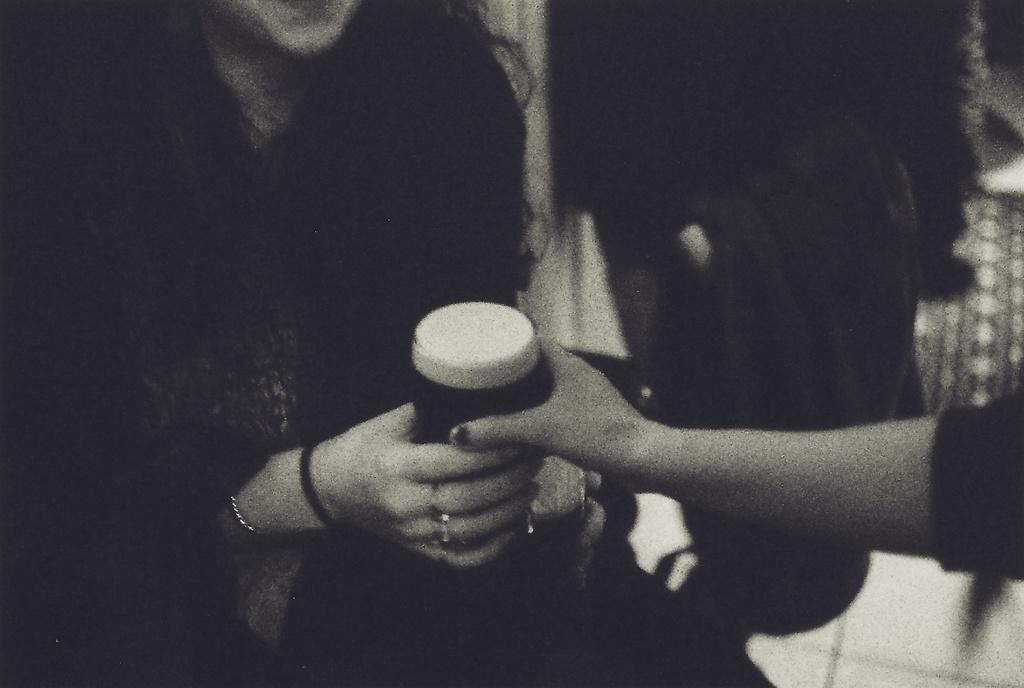What is the color scheme of the image? The image is black and white. How many people are in the image? There are two persons in the image. What are the two persons holding in their hands? The two persons are holding something in their hands, but the specific object cannot be determined from the black and white image. Can you describe the background of the image? The background of the image is blurry. What type of quartz can be seen in the shade in the image? There is no quartz or shade present in the image, as it is a black and white image of two people holding something in their hands with a blurry background. 